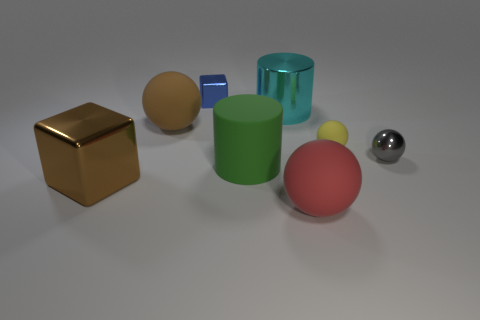Subtract all tiny yellow balls. How many balls are left? 3 Subtract all yellow balls. How many balls are left? 3 Subtract 2 balls. How many balls are left? 2 Add 1 yellow rubber balls. How many objects exist? 9 Subtract all cubes. How many objects are left? 6 Subtract all brown spheres. Subtract all green cylinders. How many spheres are left? 3 Subtract all large metallic objects. Subtract all large green cylinders. How many objects are left? 5 Add 8 tiny shiny blocks. How many tiny shiny blocks are left? 9 Add 7 tiny shiny things. How many tiny shiny things exist? 9 Subtract 0 red cylinders. How many objects are left? 8 